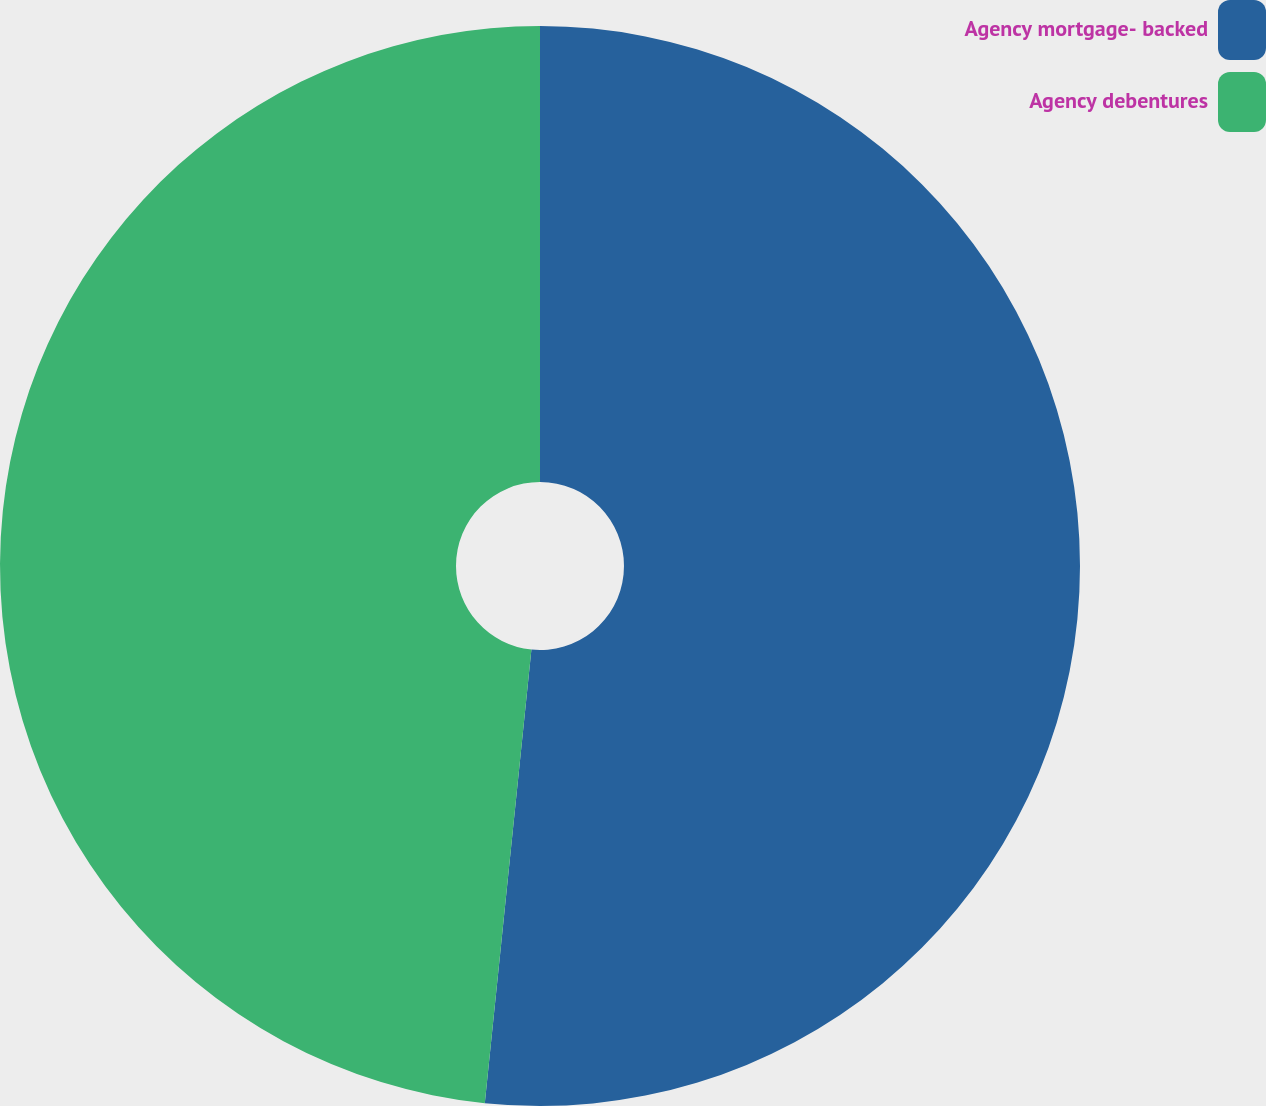Convert chart to OTSL. <chart><loc_0><loc_0><loc_500><loc_500><pie_chart><fcel>Agency mortgage- backed<fcel>Agency debentures<nl><fcel>51.63%<fcel>48.37%<nl></chart> 